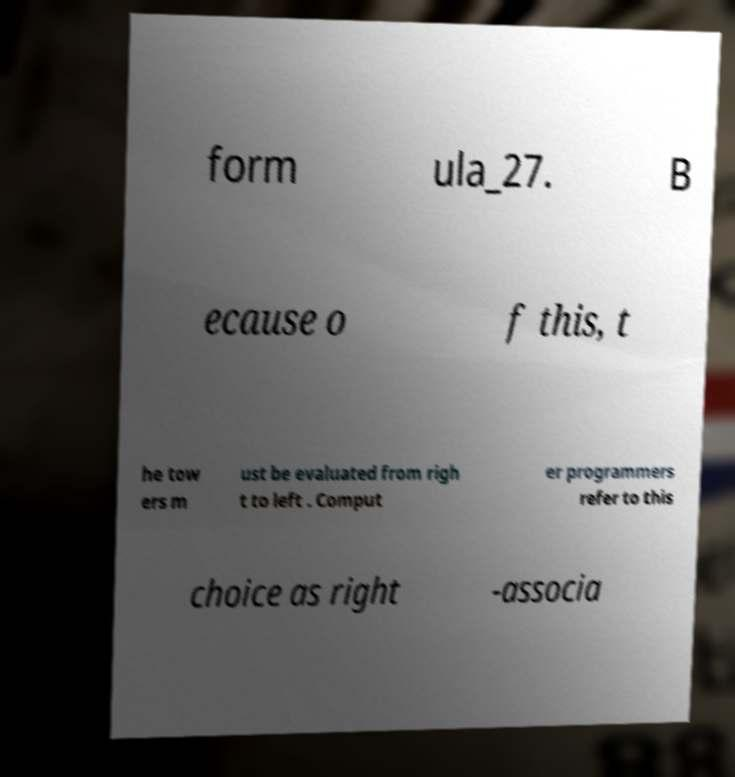For documentation purposes, I need the text within this image transcribed. Could you provide that? form ula_27. B ecause o f this, t he tow ers m ust be evaluated from righ t to left . Comput er programmers refer to this choice as right -associa 